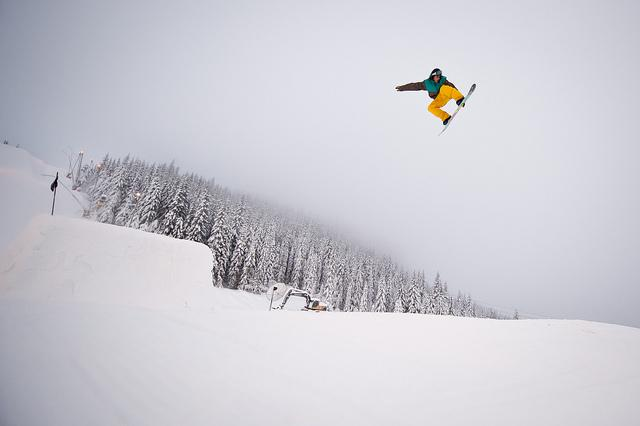How skilled is this skier in the activity?

Choices:
A) intermediate
B) professional
C) amateur
D) beginner professional 